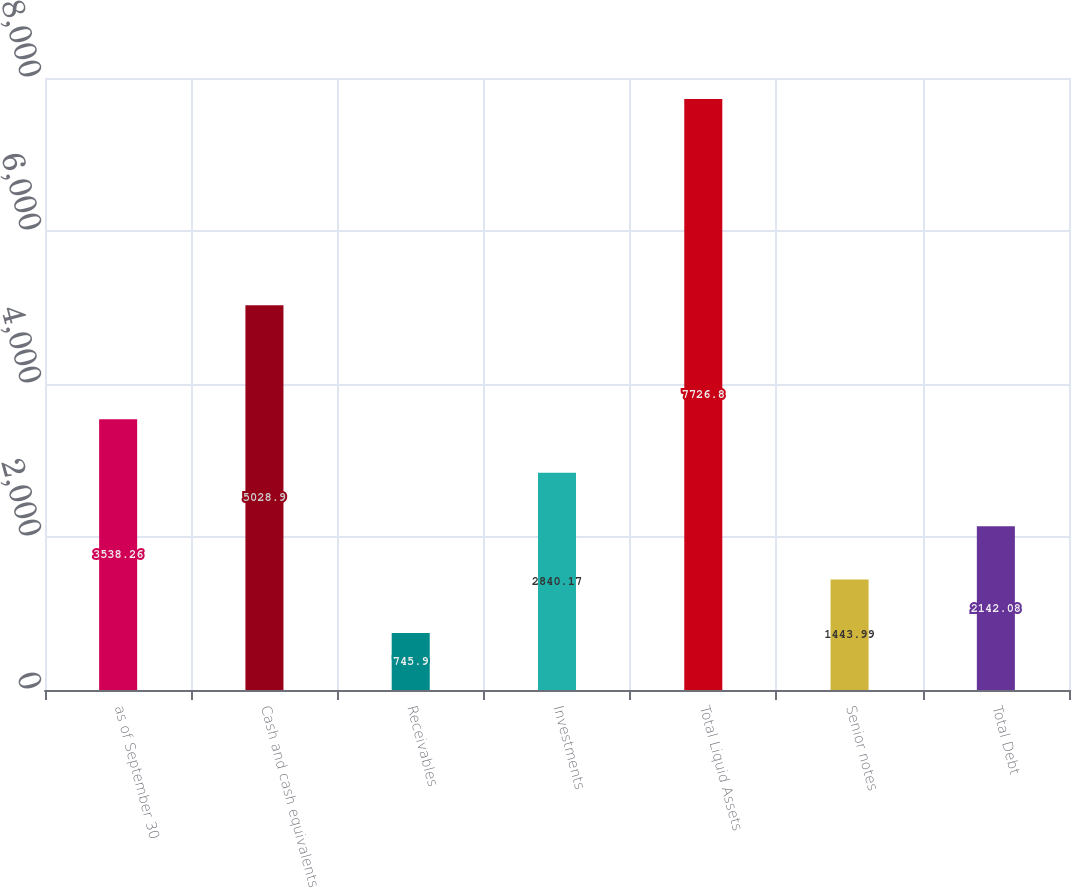<chart> <loc_0><loc_0><loc_500><loc_500><bar_chart><fcel>as of September 30<fcel>Cash and cash equivalents<fcel>Receivables<fcel>Investments<fcel>Total Liquid Assets<fcel>Senior notes<fcel>Total Debt<nl><fcel>3538.26<fcel>5028.9<fcel>745.9<fcel>2840.17<fcel>7726.8<fcel>1443.99<fcel>2142.08<nl></chart> 